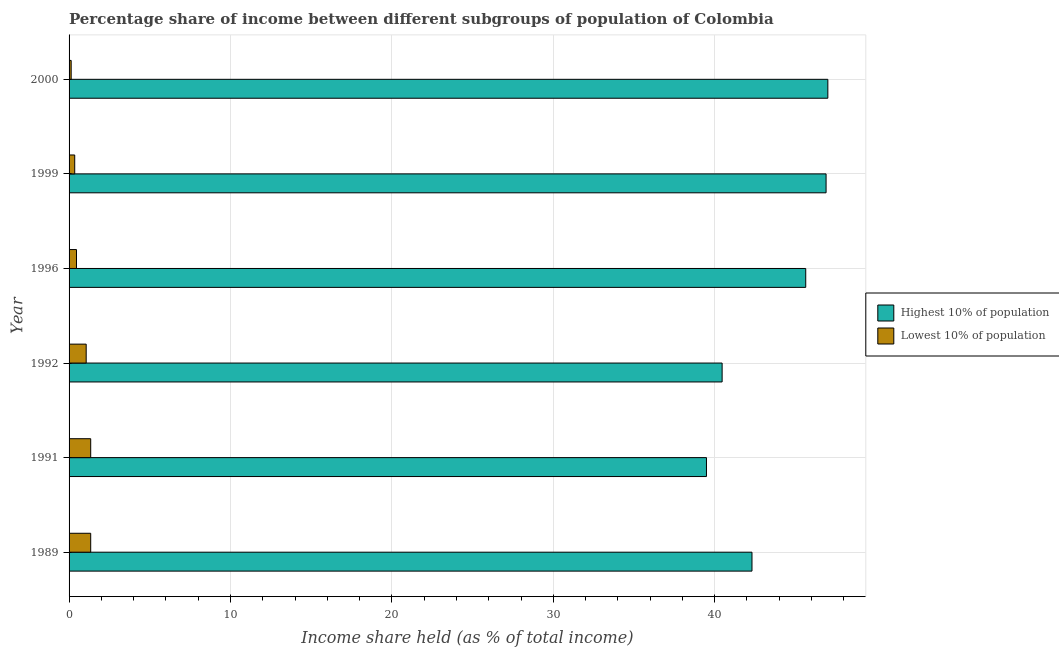Are the number of bars per tick equal to the number of legend labels?
Give a very brief answer. Yes. Are the number of bars on each tick of the Y-axis equal?
Your answer should be compact. Yes. How many bars are there on the 6th tick from the top?
Make the answer very short. 2. What is the label of the 5th group of bars from the top?
Make the answer very short. 1991. What is the income share held by highest 10% of the population in 1989?
Offer a very short reply. 42.31. Across all years, what is the maximum income share held by highest 10% of the population?
Ensure brevity in your answer.  47.01. Across all years, what is the minimum income share held by highest 10% of the population?
Your response must be concise. 39.49. In which year was the income share held by lowest 10% of the population maximum?
Provide a short and direct response. 1989. What is the total income share held by highest 10% of the population in the graph?
Provide a succinct answer. 261.81. What is the difference between the income share held by highest 10% of the population in 1996 and that in 1999?
Ensure brevity in your answer.  -1.26. What is the difference between the income share held by highest 10% of the population in 2000 and the income share held by lowest 10% of the population in 1992?
Give a very brief answer. 45.95. What is the average income share held by lowest 10% of the population per year?
Keep it short and to the point. 0.78. In the year 1989, what is the difference between the income share held by lowest 10% of the population and income share held by highest 10% of the population?
Your answer should be compact. -40.97. In how many years, is the income share held by highest 10% of the population greater than 28 %?
Offer a very short reply. 6. What is the ratio of the income share held by highest 10% of the population in 1991 to that in 1996?
Make the answer very short. 0.86. Is the difference between the income share held by highest 10% of the population in 1989 and 1992 greater than the difference between the income share held by lowest 10% of the population in 1989 and 1992?
Make the answer very short. Yes. What is the difference between the highest and the second highest income share held by highest 10% of the population?
Offer a very short reply. 0.11. What is the difference between the highest and the lowest income share held by lowest 10% of the population?
Make the answer very short. 1.21. In how many years, is the income share held by lowest 10% of the population greater than the average income share held by lowest 10% of the population taken over all years?
Give a very brief answer. 3. What does the 2nd bar from the top in 1992 represents?
Keep it short and to the point. Highest 10% of population. What does the 2nd bar from the bottom in 1992 represents?
Offer a terse response. Lowest 10% of population. How many bars are there?
Your response must be concise. 12. How many years are there in the graph?
Give a very brief answer. 6. What is the difference between two consecutive major ticks on the X-axis?
Your answer should be compact. 10. Are the values on the major ticks of X-axis written in scientific E-notation?
Your response must be concise. No. What is the title of the graph?
Your answer should be very brief. Percentage share of income between different subgroups of population of Colombia. Does "Primary school" appear as one of the legend labels in the graph?
Give a very brief answer. No. What is the label or title of the X-axis?
Provide a succinct answer. Income share held (as % of total income). What is the Income share held (as % of total income) of Highest 10% of population in 1989?
Your response must be concise. 42.31. What is the Income share held (as % of total income) of Lowest 10% of population in 1989?
Offer a very short reply. 1.34. What is the Income share held (as % of total income) of Highest 10% of population in 1991?
Ensure brevity in your answer.  39.49. What is the Income share held (as % of total income) in Lowest 10% of population in 1991?
Offer a terse response. 1.34. What is the Income share held (as % of total income) of Highest 10% of population in 1992?
Give a very brief answer. 40.46. What is the Income share held (as % of total income) of Lowest 10% of population in 1992?
Offer a terse response. 1.06. What is the Income share held (as % of total income) of Highest 10% of population in 1996?
Offer a very short reply. 45.64. What is the Income share held (as % of total income) in Lowest 10% of population in 1996?
Your answer should be very brief. 0.46. What is the Income share held (as % of total income) of Highest 10% of population in 1999?
Offer a terse response. 46.9. What is the Income share held (as % of total income) of Lowest 10% of population in 1999?
Keep it short and to the point. 0.35. What is the Income share held (as % of total income) in Highest 10% of population in 2000?
Your answer should be compact. 47.01. What is the Income share held (as % of total income) of Lowest 10% of population in 2000?
Your answer should be compact. 0.13. Across all years, what is the maximum Income share held (as % of total income) in Highest 10% of population?
Your answer should be compact. 47.01. Across all years, what is the maximum Income share held (as % of total income) of Lowest 10% of population?
Your answer should be compact. 1.34. Across all years, what is the minimum Income share held (as % of total income) of Highest 10% of population?
Make the answer very short. 39.49. Across all years, what is the minimum Income share held (as % of total income) in Lowest 10% of population?
Provide a succinct answer. 0.13. What is the total Income share held (as % of total income) in Highest 10% of population in the graph?
Your answer should be very brief. 261.81. What is the total Income share held (as % of total income) in Lowest 10% of population in the graph?
Offer a very short reply. 4.68. What is the difference between the Income share held (as % of total income) in Highest 10% of population in 1989 and that in 1991?
Ensure brevity in your answer.  2.82. What is the difference between the Income share held (as % of total income) in Lowest 10% of population in 1989 and that in 1991?
Offer a terse response. 0. What is the difference between the Income share held (as % of total income) of Highest 10% of population in 1989 and that in 1992?
Keep it short and to the point. 1.85. What is the difference between the Income share held (as % of total income) of Lowest 10% of population in 1989 and that in 1992?
Offer a terse response. 0.28. What is the difference between the Income share held (as % of total income) in Highest 10% of population in 1989 and that in 1996?
Make the answer very short. -3.33. What is the difference between the Income share held (as % of total income) of Highest 10% of population in 1989 and that in 1999?
Offer a very short reply. -4.59. What is the difference between the Income share held (as % of total income) of Lowest 10% of population in 1989 and that in 2000?
Give a very brief answer. 1.21. What is the difference between the Income share held (as % of total income) in Highest 10% of population in 1991 and that in 1992?
Offer a terse response. -0.97. What is the difference between the Income share held (as % of total income) of Lowest 10% of population in 1991 and that in 1992?
Make the answer very short. 0.28. What is the difference between the Income share held (as % of total income) of Highest 10% of population in 1991 and that in 1996?
Provide a short and direct response. -6.15. What is the difference between the Income share held (as % of total income) in Highest 10% of population in 1991 and that in 1999?
Ensure brevity in your answer.  -7.41. What is the difference between the Income share held (as % of total income) in Highest 10% of population in 1991 and that in 2000?
Make the answer very short. -7.52. What is the difference between the Income share held (as % of total income) in Lowest 10% of population in 1991 and that in 2000?
Ensure brevity in your answer.  1.21. What is the difference between the Income share held (as % of total income) of Highest 10% of population in 1992 and that in 1996?
Provide a short and direct response. -5.18. What is the difference between the Income share held (as % of total income) of Highest 10% of population in 1992 and that in 1999?
Provide a succinct answer. -6.44. What is the difference between the Income share held (as % of total income) in Lowest 10% of population in 1992 and that in 1999?
Keep it short and to the point. 0.71. What is the difference between the Income share held (as % of total income) in Highest 10% of population in 1992 and that in 2000?
Offer a terse response. -6.55. What is the difference between the Income share held (as % of total income) of Highest 10% of population in 1996 and that in 1999?
Offer a terse response. -1.26. What is the difference between the Income share held (as % of total income) in Lowest 10% of population in 1996 and that in 1999?
Offer a very short reply. 0.11. What is the difference between the Income share held (as % of total income) of Highest 10% of population in 1996 and that in 2000?
Your answer should be compact. -1.37. What is the difference between the Income share held (as % of total income) in Lowest 10% of population in 1996 and that in 2000?
Provide a succinct answer. 0.33. What is the difference between the Income share held (as % of total income) in Highest 10% of population in 1999 and that in 2000?
Offer a very short reply. -0.11. What is the difference between the Income share held (as % of total income) of Lowest 10% of population in 1999 and that in 2000?
Offer a very short reply. 0.22. What is the difference between the Income share held (as % of total income) of Highest 10% of population in 1989 and the Income share held (as % of total income) of Lowest 10% of population in 1991?
Your answer should be very brief. 40.97. What is the difference between the Income share held (as % of total income) of Highest 10% of population in 1989 and the Income share held (as % of total income) of Lowest 10% of population in 1992?
Keep it short and to the point. 41.25. What is the difference between the Income share held (as % of total income) in Highest 10% of population in 1989 and the Income share held (as % of total income) in Lowest 10% of population in 1996?
Provide a short and direct response. 41.85. What is the difference between the Income share held (as % of total income) of Highest 10% of population in 1989 and the Income share held (as % of total income) of Lowest 10% of population in 1999?
Ensure brevity in your answer.  41.96. What is the difference between the Income share held (as % of total income) in Highest 10% of population in 1989 and the Income share held (as % of total income) in Lowest 10% of population in 2000?
Ensure brevity in your answer.  42.18. What is the difference between the Income share held (as % of total income) of Highest 10% of population in 1991 and the Income share held (as % of total income) of Lowest 10% of population in 1992?
Provide a succinct answer. 38.43. What is the difference between the Income share held (as % of total income) of Highest 10% of population in 1991 and the Income share held (as % of total income) of Lowest 10% of population in 1996?
Your answer should be very brief. 39.03. What is the difference between the Income share held (as % of total income) of Highest 10% of population in 1991 and the Income share held (as % of total income) of Lowest 10% of population in 1999?
Keep it short and to the point. 39.14. What is the difference between the Income share held (as % of total income) of Highest 10% of population in 1991 and the Income share held (as % of total income) of Lowest 10% of population in 2000?
Give a very brief answer. 39.36. What is the difference between the Income share held (as % of total income) in Highest 10% of population in 1992 and the Income share held (as % of total income) in Lowest 10% of population in 1996?
Your response must be concise. 40. What is the difference between the Income share held (as % of total income) of Highest 10% of population in 1992 and the Income share held (as % of total income) of Lowest 10% of population in 1999?
Give a very brief answer. 40.11. What is the difference between the Income share held (as % of total income) of Highest 10% of population in 1992 and the Income share held (as % of total income) of Lowest 10% of population in 2000?
Provide a short and direct response. 40.33. What is the difference between the Income share held (as % of total income) in Highest 10% of population in 1996 and the Income share held (as % of total income) in Lowest 10% of population in 1999?
Your answer should be compact. 45.29. What is the difference between the Income share held (as % of total income) of Highest 10% of population in 1996 and the Income share held (as % of total income) of Lowest 10% of population in 2000?
Provide a succinct answer. 45.51. What is the difference between the Income share held (as % of total income) of Highest 10% of population in 1999 and the Income share held (as % of total income) of Lowest 10% of population in 2000?
Your answer should be compact. 46.77. What is the average Income share held (as % of total income) of Highest 10% of population per year?
Make the answer very short. 43.63. What is the average Income share held (as % of total income) in Lowest 10% of population per year?
Offer a very short reply. 0.78. In the year 1989, what is the difference between the Income share held (as % of total income) of Highest 10% of population and Income share held (as % of total income) of Lowest 10% of population?
Provide a succinct answer. 40.97. In the year 1991, what is the difference between the Income share held (as % of total income) of Highest 10% of population and Income share held (as % of total income) of Lowest 10% of population?
Provide a succinct answer. 38.15. In the year 1992, what is the difference between the Income share held (as % of total income) in Highest 10% of population and Income share held (as % of total income) in Lowest 10% of population?
Keep it short and to the point. 39.4. In the year 1996, what is the difference between the Income share held (as % of total income) in Highest 10% of population and Income share held (as % of total income) in Lowest 10% of population?
Provide a short and direct response. 45.18. In the year 1999, what is the difference between the Income share held (as % of total income) in Highest 10% of population and Income share held (as % of total income) in Lowest 10% of population?
Your response must be concise. 46.55. In the year 2000, what is the difference between the Income share held (as % of total income) in Highest 10% of population and Income share held (as % of total income) in Lowest 10% of population?
Provide a succinct answer. 46.88. What is the ratio of the Income share held (as % of total income) of Highest 10% of population in 1989 to that in 1991?
Provide a succinct answer. 1.07. What is the ratio of the Income share held (as % of total income) in Highest 10% of population in 1989 to that in 1992?
Offer a very short reply. 1.05. What is the ratio of the Income share held (as % of total income) in Lowest 10% of population in 1989 to that in 1992?
Ensure brevity in your answer.  1.26. What is the ratio of the Income share held (as % of total income) of Highest 10% of population in 1989 to that in 1996?
Ensure brevity in your answer.  0.93. What is the ratio of the Income share held (as % of total income) in Lowest 10% of population in 1989 to that in 1996?
Make the answer very short. 2.91. What is the ratio of the Income share held (as % of total income) in Highest 10% of population in 1989 to that in 1999?
Your answer should be compact. 0.9. What is the ratio of the Income share held (as % of total income) of Lowest 10% of population in 1989 to that in 1999?
Offer a very short reply. 3.83. What is the ratio of the Income share held (as % of total income) in Highest 10% of population in 1989 to that in 2000?
Provide a succinct answer. 0.9. What is the ratio of the Income share held (as % of total income) of Lowest 10% of population in 1989 to that in 2000?
Keep it short and to the point. 10.31. What is the ratio of the Income share held (as % of total income) of Highest 10% of population in 1991 to that in 1992?
Provide a short and direct response. 0.98. What is the ratio of the Income share held (as % of total income) of Lowest 10% of population in 1991 to that in 1992?
Your response must be concise. 1.26. What is the ratio of the Income share held (as % of total income) of Highest 10% of population in 1991 to that in 1996?
Your response must be concise. 0.87. What is the ratio of the Income share held (as % of total income) of Lowest 10% of population in 1991 to that in 1996?
Provide a succinct answer. 2.91. What is the ratio of the Income share held (as % of total income) of Highest 10% of population in 1991 to that in 1999?
Give a very brief answer. 0.84. What is the ratio of the Income share held (as % of total income) in Lowest 10% of population in 1991 to that in 1999?
Provide a succinct answer. 3.83. What is the ratio of the Income share held (as % of total income) in Highest 10% of population in 1991 to that in 2000?
Your response must be concise. 0.84. What is the ratio of the Income share held (as % of total income) in Lowest 10% of population in 1991 to that in 2000?
Provide a succinct answer. 10.31. What is the ratio of the Income share held (as % of total income) of Highest 10% of population in 1992 to that in 1996?
Offer a terse response. 0.89. What is the ratio of the Income share held (as % of total income) in Lowest 10% of population in 1992 to that in 1996?
Give a very brief answer. 2.3. What is the ratio of the Income share held (as % of total income) in Highest 10% of population in 1992 to that in 1999?
Your answer should be compact. 0.86. What is the ratio of the Income share held (as % of total income) in Lowest 10% of population in 1992 to that in 1999?
Keep it short and to the point. 3.03. What is the ratio of the Income share held (as % of total income) of Highest 10% of population in 1992 to that in 2000?
Offer a terse response. 0.86. What is the ratio of the Income share held (as % of total income) in Lowest 10% of population in 1992 to that in 2000?
Provide a succinct answer. 8.15. What is the ratio of the Income share held (as % of total income) of Highest 10% of population in 1996 to that in 1999?
Ensure brevity in your answer.  0.97. What is the ratio of the Income share held (as % of total income) of Lowest 10% of population in 1996 to that in 1999?
Your response must be concise. 1.31. What is the ratio of the Income share held (as % of total income) in Highest 10% of population in 1996 to that in 2000?
Offer a very short reply. 0.97. What is the ratio of the Income share held (as % of total income) in Lowest 10% of population in 1996 to that in 2000?
Give a very brief answer. 3.54. What is the ratio of the Income share held (as % of total income) in Lowest 10% of population in 1999 to that in 2000?
Provide a succinct answer. 2.69. What is the difference between the highest and the second highest Income share held (as % of total income) in Highest 10% of population?
Keep it short and to the point. 0.11. What is the difference between the highest and the second highest Income share held (as % of total income) of Lowest 10% of population?
Provide a succinct answer. 0. What is the difference between the highest and the lowest Income share held (as % of total income) in Highest 10% of population?
Your answer should be very brief. 7.52. What is the difference between the highest and the lowest Income share held (as % of total income) in Lowest 10% of population?
Provide a succinct answer. 1.21. 